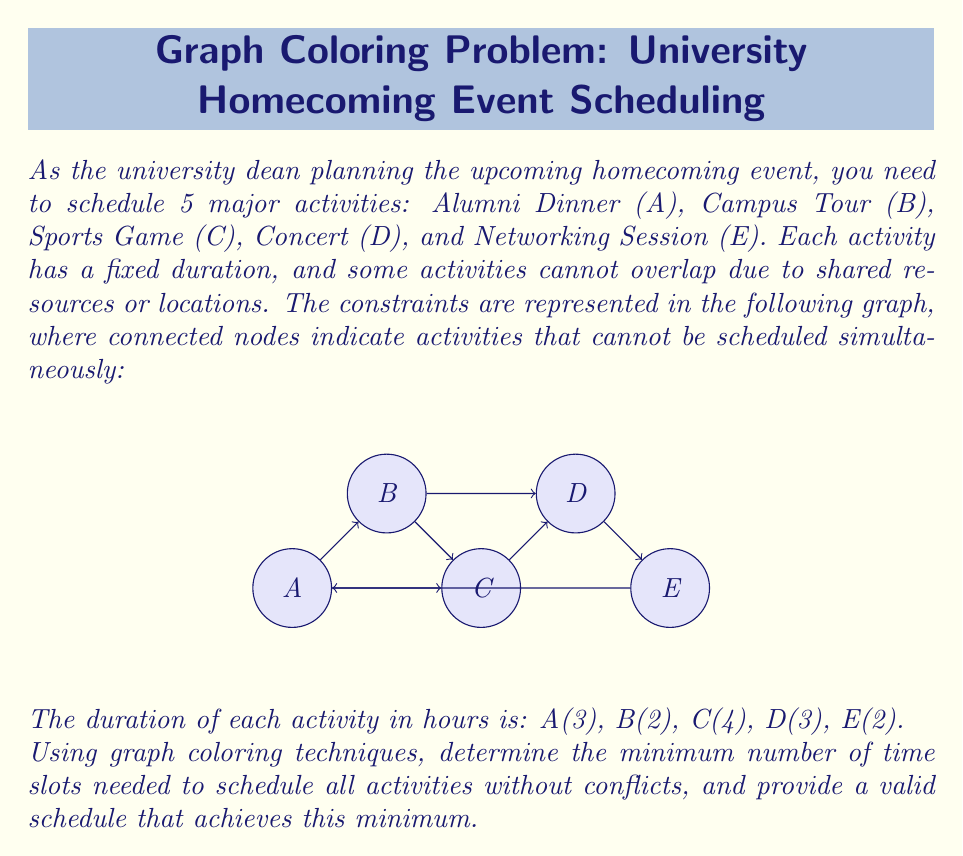What is the answer to this math problem? To solve this problem, we'll use graph coloring techniques, where each color represents a distinct time slot. The goal is to minimize the number of colors (time slots) while ensuring no adjacent nodes (conflicting activities) have the same color.

Step 1: Analyze the graph
The given graph is not a complete graph, which means some activities can be scheduled simultaneously.

Step 2: Determine the chromatic number
The chromatic number of this graph represents the minimum number of time slots needed. We can use a greedy coloring algorithm:

1. Start with activity A, assign it color 1.
2. For B, it conflicts with A, so assign color 2.
3. For C, it conflicts with A and B, so assign color 3.
4. For D, it conflicts with B and C, so assign color 1.
5. For E, it conflicts with A and D, so assign color 2.

The chromatic number is 3, meaning we need a minimum of 3 time slots.

Step 3: Create a schedule
Let's assign time slots based on the coloring:
- Time Slot 1 (Color 1): A (3 hours), D (3 hours)
- Time Slot 2 (Color 2): B (2 hours), E (2 hours)
- Time Slot 3 (Color 3): C (4 hours)

Step 4: Optimize the schedule
To minimize the total duration, we can arrange the time slots as follows:
1. Start with the longest slot (Time Slot 3): C (4 hours)
2. Follow with Time Slot 1: A (3 hours), then D (3 hours)
3. End with Time Slot 2: B (2 hours), then E (2 hours)

The optimized schedule has a total duration of 14 hours and can be represented as:

$$\text{C (4h)} \rightarrow \text{A (3h)} \rightarrow \text{D (3h)} \rightarrow \text{B (2h)} \rightarrow \text{E (2h)}$$

This schedule ensures no conflicts between activities and minimizes the number of time slots used.
Answer: 3 time slots; Schedule: C → A → D → B → E 